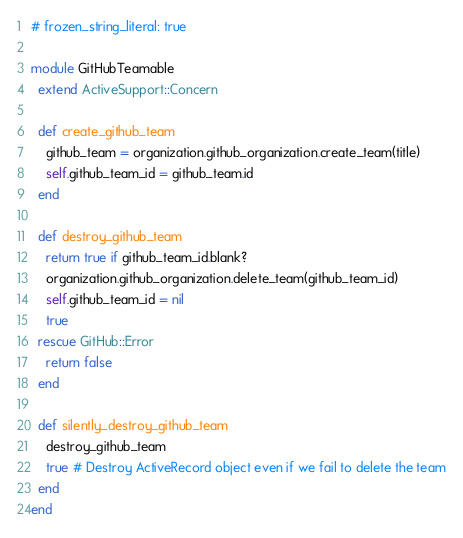Convert code to text. <code><loc_0><loc_0><loc_500><loc_500><_Ruby_># frozen_string_literal: true

module GitHubTeamable
  extend ActiveSupport::Concern

  def create_github_team
    github_team = organization.github_organization.create_team(title)
    self.github_team_id = github_team.id
  end

  def destroy_github_team
    return true if github_team_id.blank?
    organization.github_organization.delete_team(github_team_id)
    self.github_team_id = nil
    true
  rescue GitHub::Error
    return false
  end

  def silently_destroy_github_team
    destroy_github_team
    true # Destroy ActiveRecord object even if we fail to delete the team
  end
end
</code> 